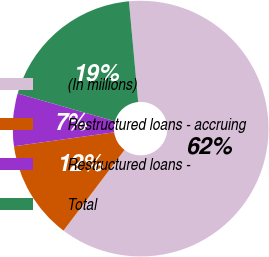Convert chart. <chart><loc_0><loc_0><loc_500><loc_500><pie_chart><fcel>(In millions)<fcel>Restructured loans - accruing<fcel>Restructured loans -<fcel>Total<nl><fcel>61.76%<fcel>12.49%<fcel>6.63%<fcel>19.12%<nl></chart> 